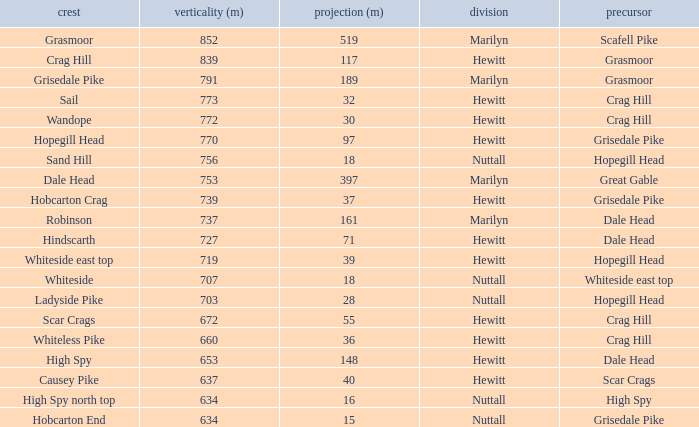Which Parent has height smaller than 756 and a Prom of 39? Hopegill Head. 